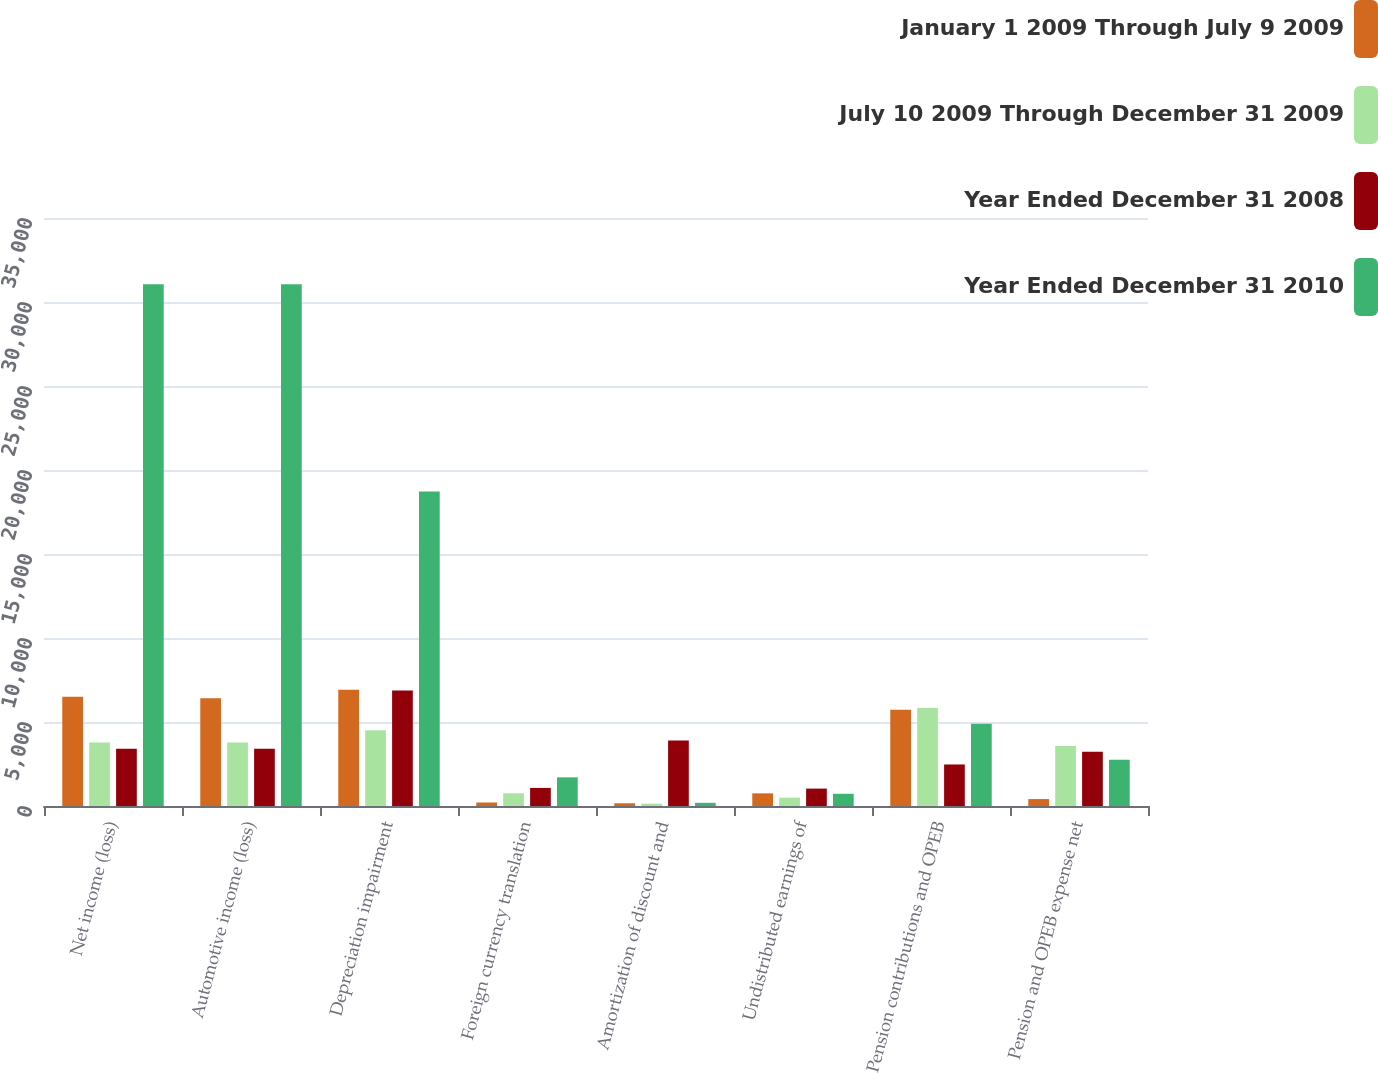<chart> <loc_0><loc_0><loc_500><loc_500><stacked_bar_chart><ecel><fcel>Net income (loss)<fcel>Automotive income (loss)<fcel>Depreciation impairment<fcel>Foreign currency translation<fcel>Amortization of discount and<fcel>Undistributed earnings of<fcel>Pension contributions and OPEB<fcel>Pension and OPEB expense net<nl><fcel>January 1 2009 Through July 9 2009<fcel>6503<fcel>6413<fcel>6923<fcel>209<fcel>163<fcel>753<fcel>5723<fcel>412<nl><fcel>July 10 2009 Through December 31 2009<fcel>3786<fcel>3786<fcel>4511<fcel>755<fcel>140<fcel>497<fcel>5832<fcel>3570<nl><fcel>Year Ended December 31 2008<fcel>3402<fcel>3402<fcel>6873<fcel>1077<fcel>3897<fcel>1036<fcel>2472<fcel>3234<nl><fcel>Year Ended December 31 2010<fcel>31051<fcel>31051<fcel>18724<fcel>1705<fcel>189<fcel>727<fcel>4898<fcel>2747<nl></chart> 